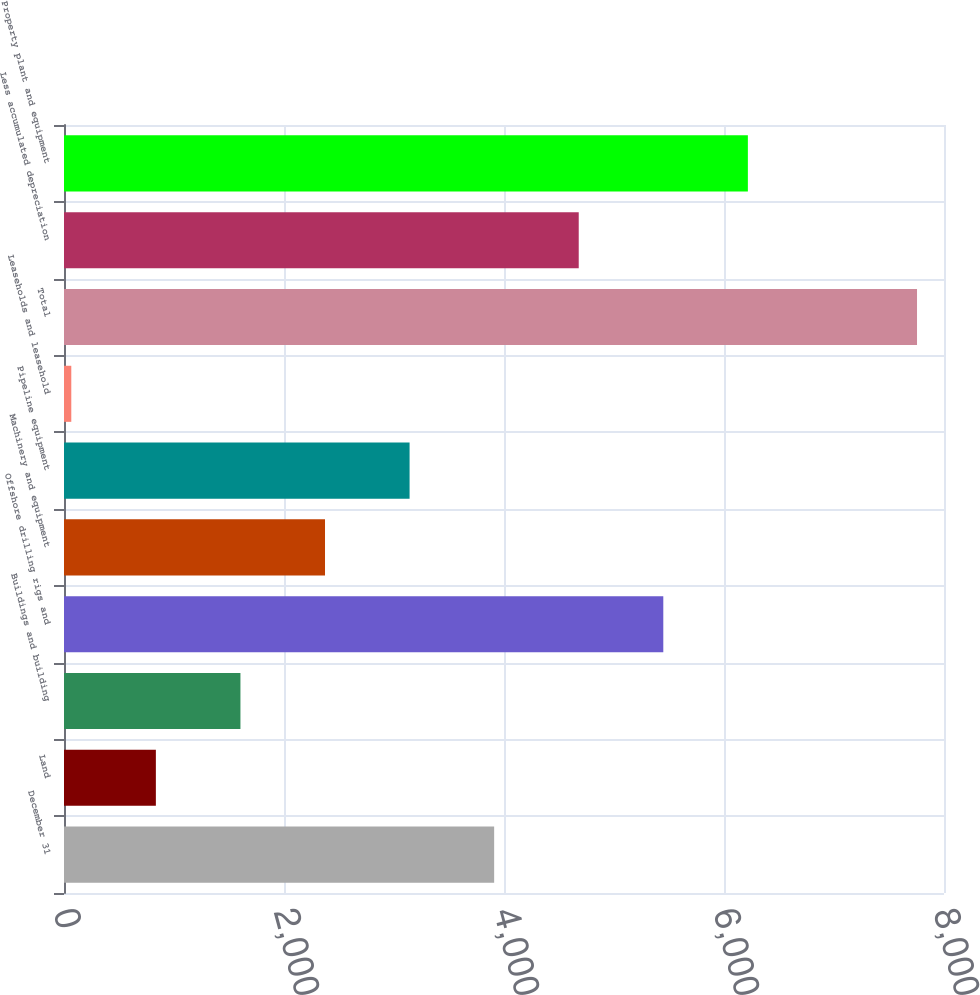Convert chart to OTSL. <chart><loc_0><loc_0><loc_500><loc_500><bar_chart><fcel>December 31<fcel>Land<fcel>Buildings and building<fcel>Offshore drilling rigs and<fcel>Machinery and equipment<fcel>Pipeline equipment<fcel>Leaseholds and leasehold<fcel>Total<fcel>Less accumulated depreciation<fcel>Property plant and equipment<nl><fcel>3910.5<fcel>835.14<fcel>1603.98<fcel>5448.18<fcel>2372.82<fcel>3141.66<fcel>66.3<fcel>7754.7<fcel>4679.34<fcel>6217.02<nl></chart> 